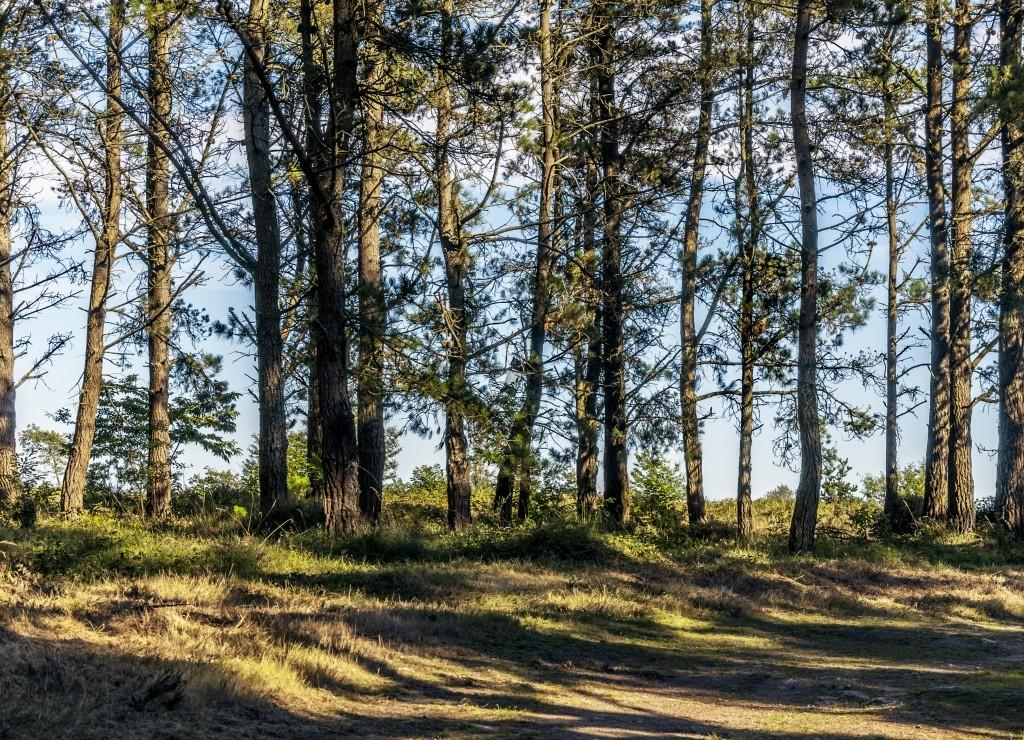What type of vegetation can be seen in the image? There are trees in the image. What is present at the bottom of the image? There is grass at the bottom of the image. What can be seen in the background of the image? The sky is visible in the background of the image. How does the pail contribute to the growth of the quince in the image? There is no pail or quince present in the image, so this question cannot be answered. 